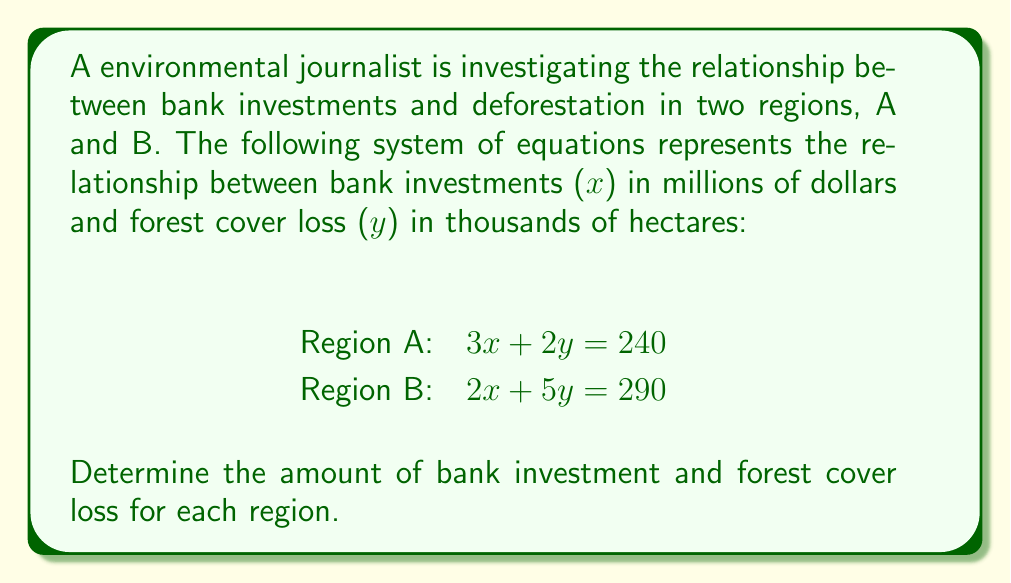Teach me how to tackle this problem. To solve this system of equations, we'll use the elimination method:

1) Multiply the first equation by 5 and the second equation by -2:
   Region A: $15x + 10y = 1200$
   Region B: $-4x - 10y = -580$

2) Add these equations to eliminate y:
   $11x = 620$

3) Solve for x:
   $x = 620 / 11 = 56.36$

4) Substitute this value of x into one of the original equations, say Region A:
   $3(56.36) + 2y = 240$
   $169.08 + 2y = 240$
   $2y = 70.92$
   $y = 35.46$

5) Check the solution in the second equation:
   $2(56.36) + 5(35.46) = 290$
   $112.72 + 177.3 = 290$
   $290 = 290$ (equation holds)

Therefore, the bank investment (x) is $56.36 million and the forest cover loss (y) is 35.46 thousand hectares for both regions.
Answer: $x = 56.36, y = 35.46$ 